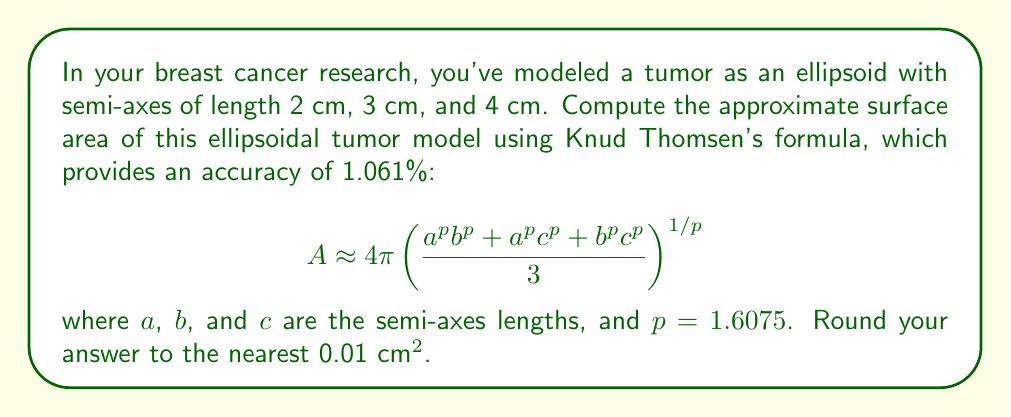Provide a solution to this math problem. Let's approach this step-by-step:

1) We have the semi-axes lengths:
   $a = 2$ cm, $b = 3$ cm, $c = 4$ cm

2) We'll use Knud Thomsen's formula with $p = 1.6075$:
   $$A \approx 4\pi \left(\frac{a^p b^p + a^p c^p + b^p c^p}{3}\right)^{1/p}$$

3) Let's calculate each term inside the parentheses:
   $a^p = 2^{1.6075} \approx 3.0357$
   $b^p = 3^{1.6075} \approx 5.4188$
   $c^p = 4^{1.6075} \approx 8.0952$

4) Now, let's sum the products:
   $a^p b^p = 3.0357 \times 5.4188 \approx 164.4789$
   $a^p c^p = 3.0357 \times 8.0952 \approx 245.7456$
   $b^p c^p = 5.4188 \times 8.0952 \approx 438.6545$

5) Sum these and divide by 3:
   $\frac{164.4789 + 245.7456 + 438.6545}{3} \approx 282.9597$

6) Take this to the power of $1/p$:
   $282.9597^{1/1.6075} \approx 11.7914$

7) Multiply by $4\pi$:
   $4\pi \times 11.7914 \approx 148.0507$

8) Rounding to the nearest 0.01:
   $148.05$ cm²
Answer: 148.05 cm² 